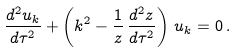<formula> <loc_0><loc_0><loc_500><loc_500>\frac { d ^ { 2 } u _ { k } } { d \tau ^ { 2 } } + \left ( k ^ { 2 } - \frac { 1 } { z } \, \frac { d ^ { 2 } z } { d \tau ^ { 2 } } \right ) \, u _ { k } = 0 \, .</formula> 